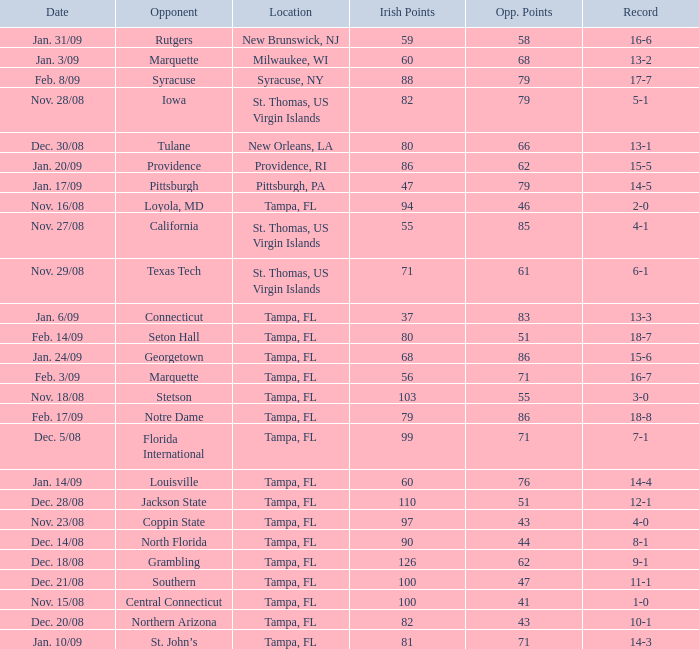What is the record where the locaiton is tampa, fl and the opponent is louisville? 14-4. 